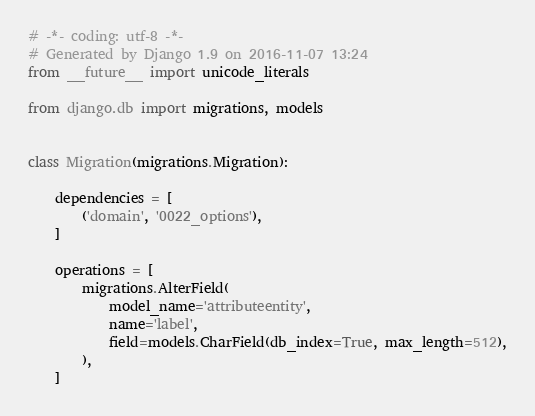Convert code to text. <code><loc_0><loc_0><loc_500><loc_500><_Python_># -*- coding: utf-8 -*-
# Generated by Django 1.9 on 2016-11-07 13:24
from __future__ import unicode_literals

from django.db import migrations, models


class Migration(migrations.Migration):

    dependencies = [
        ('domain', '0022_options'),
    ]

    operations = [
        migrations.AlterField(
            model_name='attributeentity',
            name='label',
            field=models.CharField(db_index=True, max_length=512),
        ),
    ]
</code> 